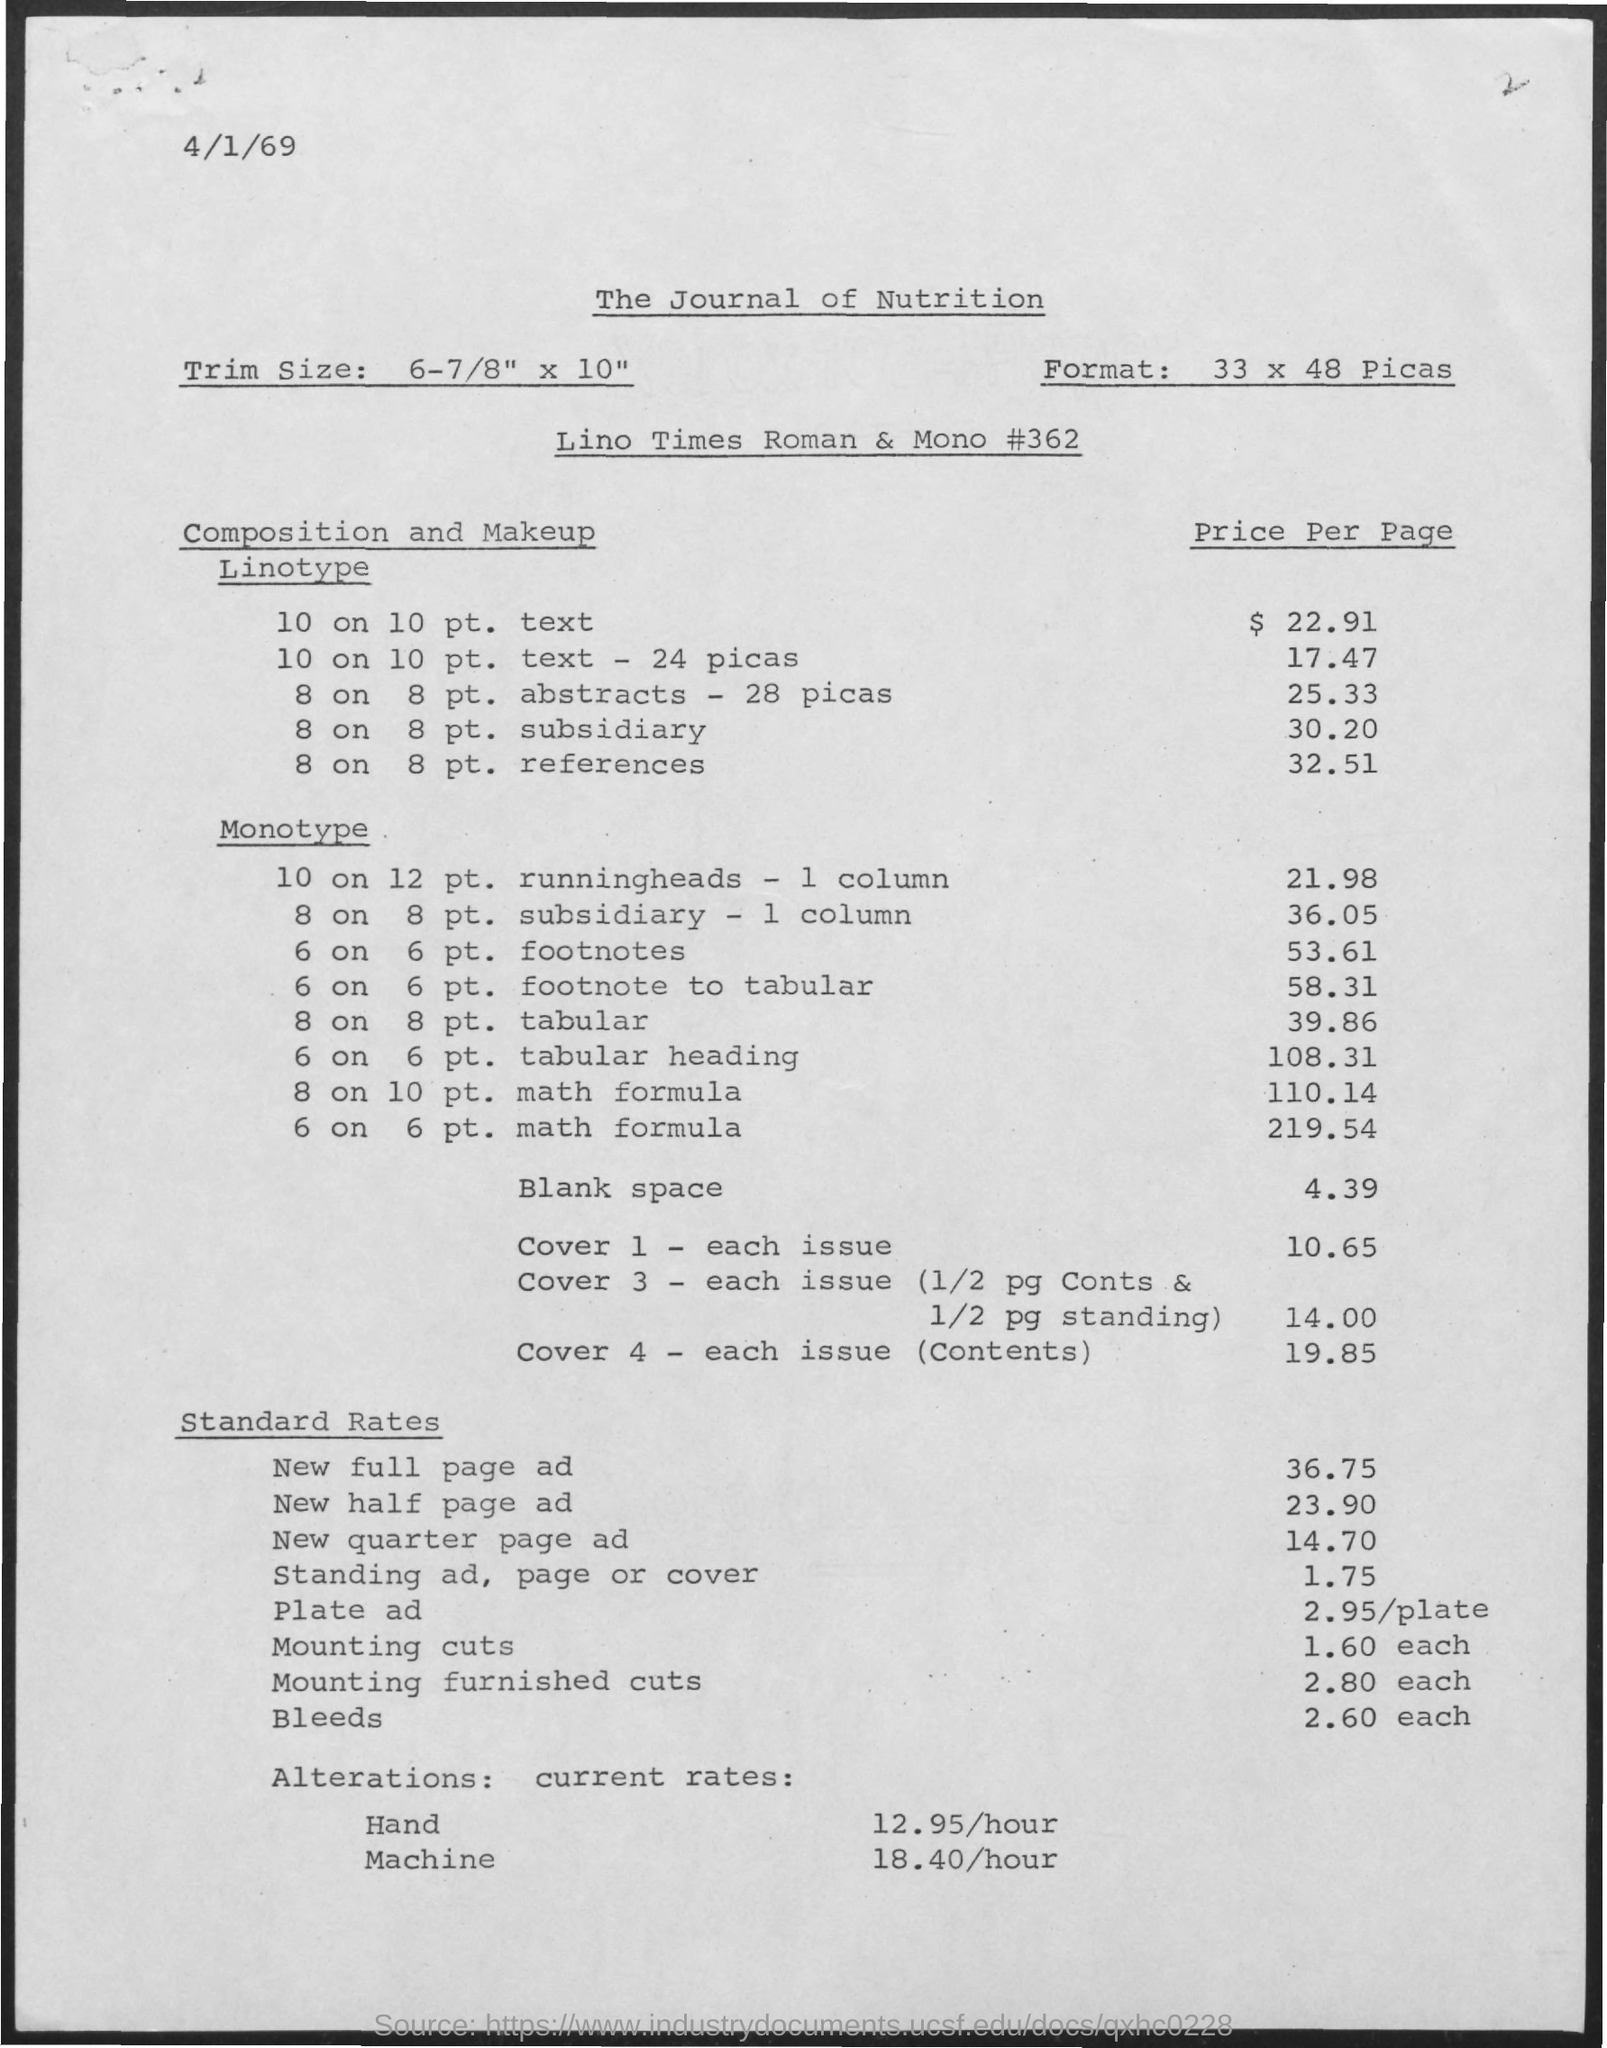List a handful of essential elements in this visual. The price per page for a linotype of 8 on 8pt abstracts with a lead distance of -28 picas is 25.33. The trim size of this book is 6-7/8 inches x 10 inches. As of the current date, April 1st, 1969 is the top date displayed on this page. The price for a Monotype of 10 on 12pt running heads - 1 column is $21.98. The title at the top of the page is 'The Journal of Nutrition'. 